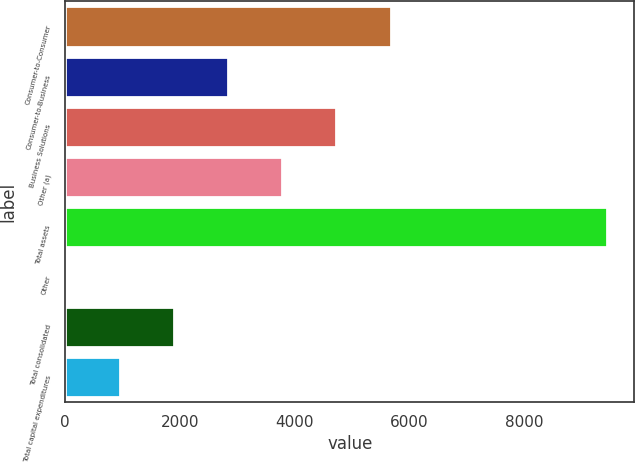Convert chart. <chart><loc_0><loc_0><loc_500><loc_500><bar_chart><fcel>Consumer-to-Consumer<fcel>Consumer-to-Business<fcel>Business Solutions<fcel>Other (a)<fcel>Total assets<fcel>Other<fcel>Total consolidated<fcel>Total capital expenditures<nl><fcel>5672.6<fcel>2840.15<fcel>4728.45<fcel>3784.3<fcel>9449.2<fcel>7.7<fcel>1896<fcel>951.85<nl></chart> 